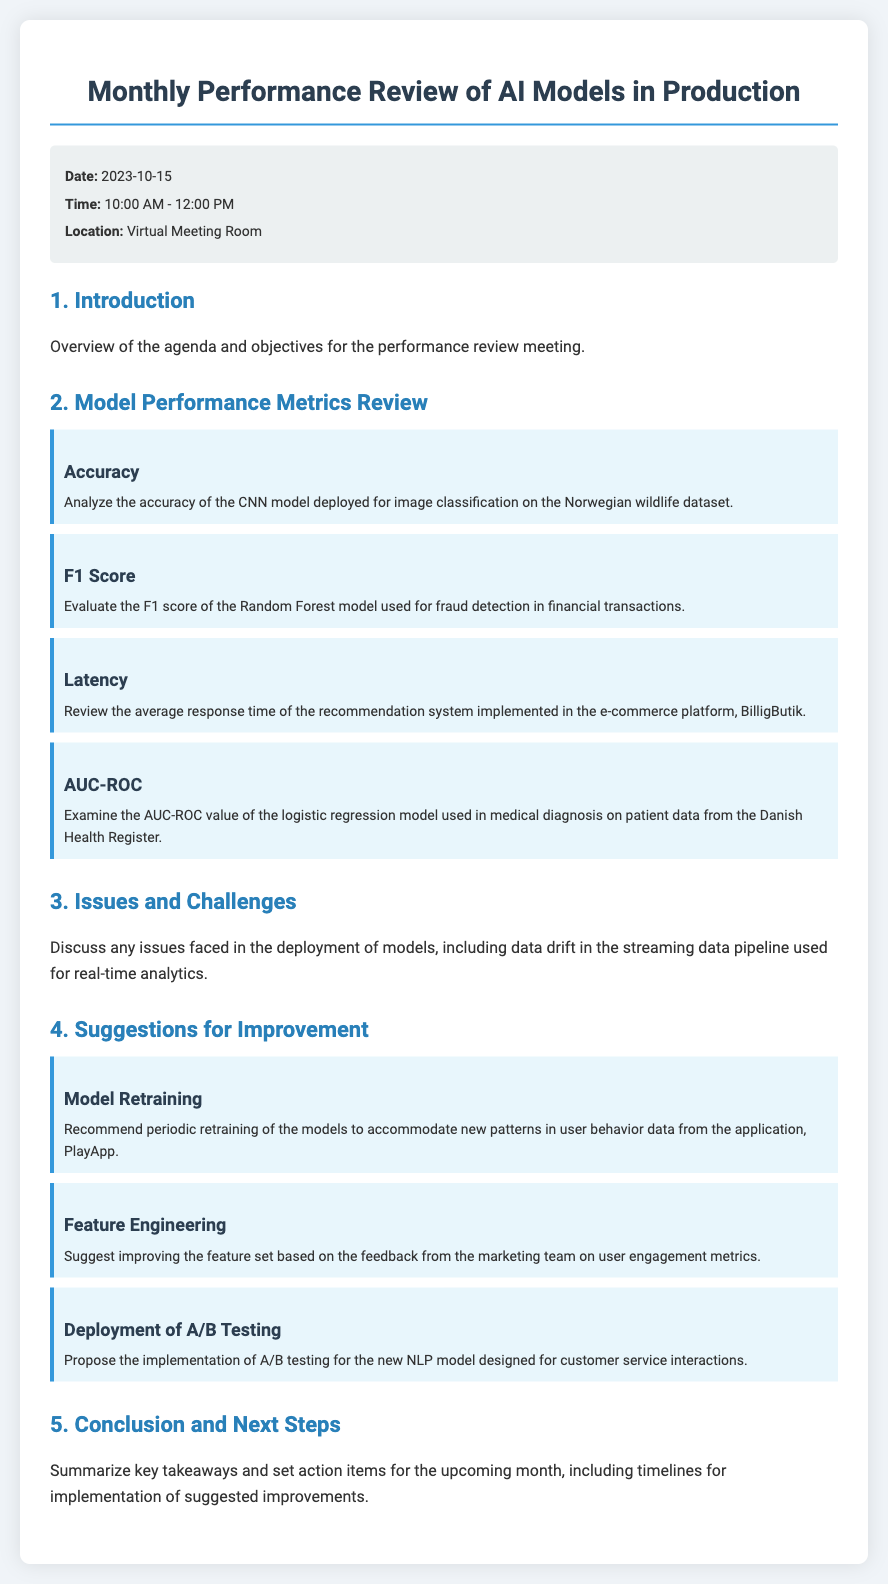What is the date of the meeting? The date of the meeting is specified in the document under the meeting info section.
Answer: 2023-10-15 What model's accuracy is being analyzed? The document mentions a CNN model deployed for image classification on a specific dataset.
Answer: CNN model What is the F1 score being evaluated for? The document explicitly states that the F1 score is evaluated for a certain model used for fraud detection.
Answer: Random Forest model What issue is discussed regarding model deployment? The document outlines a specific challenge related to data management in model deployment.
Answer: Data drift What is one suggestion for improving model performance? The document lists suggestions that include periodic actions to enhance model performance.
Answer: Model retraining How is the recommendation system's average response time referred to? The document reviews the performance metrics related to the implementation of this system.
Answer: Latency What is the proposed testing method for the new NLP model? The document suggests a specific validation method to be implemented for testing purposes.
Answer: A/B testing What model is used for medical diagnosis? The document identifies the specific model used in healthcare applications.
Answer: Logistic regression model What is the meeting location? The meeting location is specified in the document under the meeting info section.
Answer: Virtual Meeting Room 